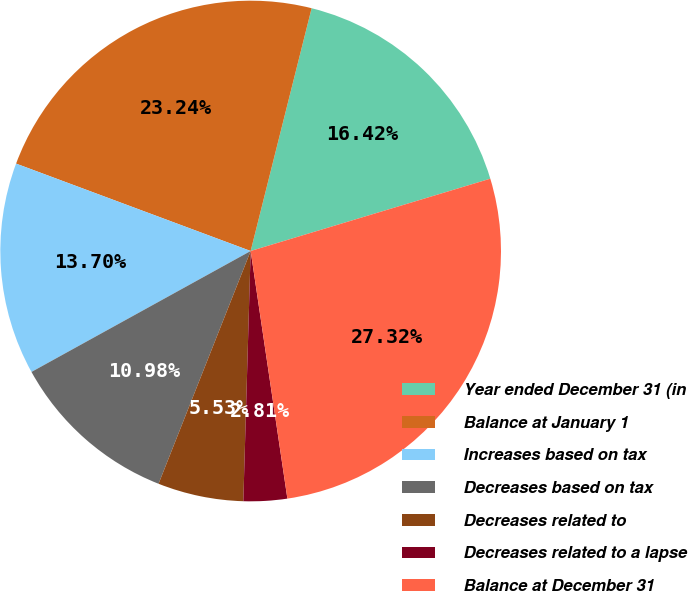<chart> <loc_0><loc_0><loc_500><loc_500><pie_chart><fcel>Year ended December 31 (in<fcel>Balance at January 1<fcel>Increases based on tax<fcel>Decreases based on tax<fcel>Decreases related to<fcel>Decreases related to a lapse<fcel>Balance at December 31<nl><fcel>16.42%<fcel>23.24%<fcel>13.7%<fcel>10.98%<fcel>5.53%<fcel>2.81%<fcel>27.32%<nl></chart> 